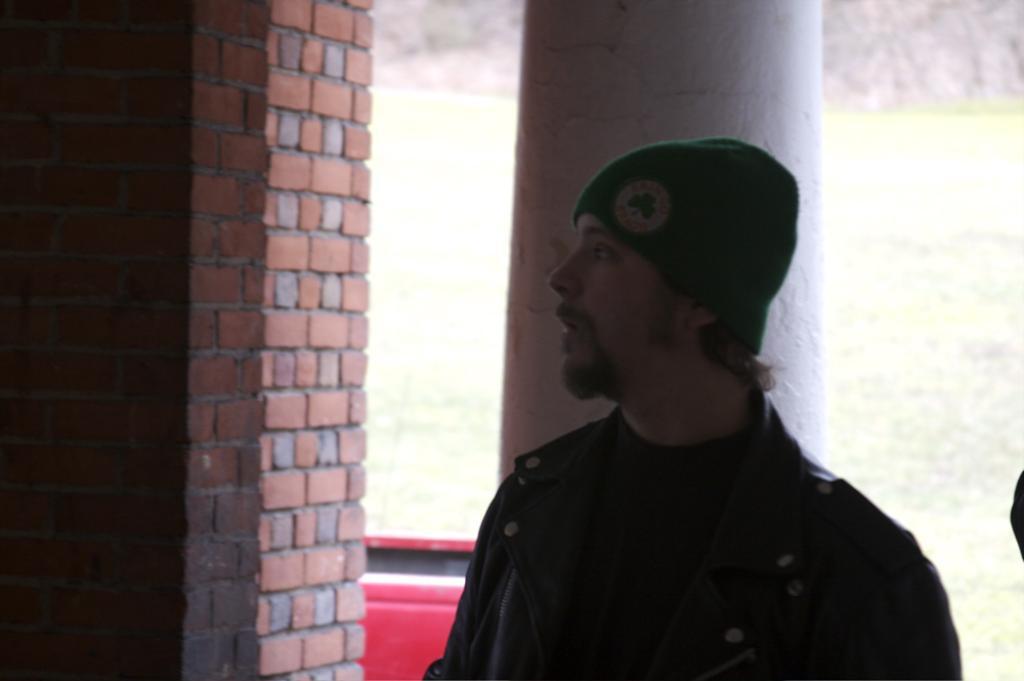Describe this image in one or two sentences. In this image there is a man standing. Behind him there is a pillar. To the left there is a wall. In the background there's grass on the ground. 